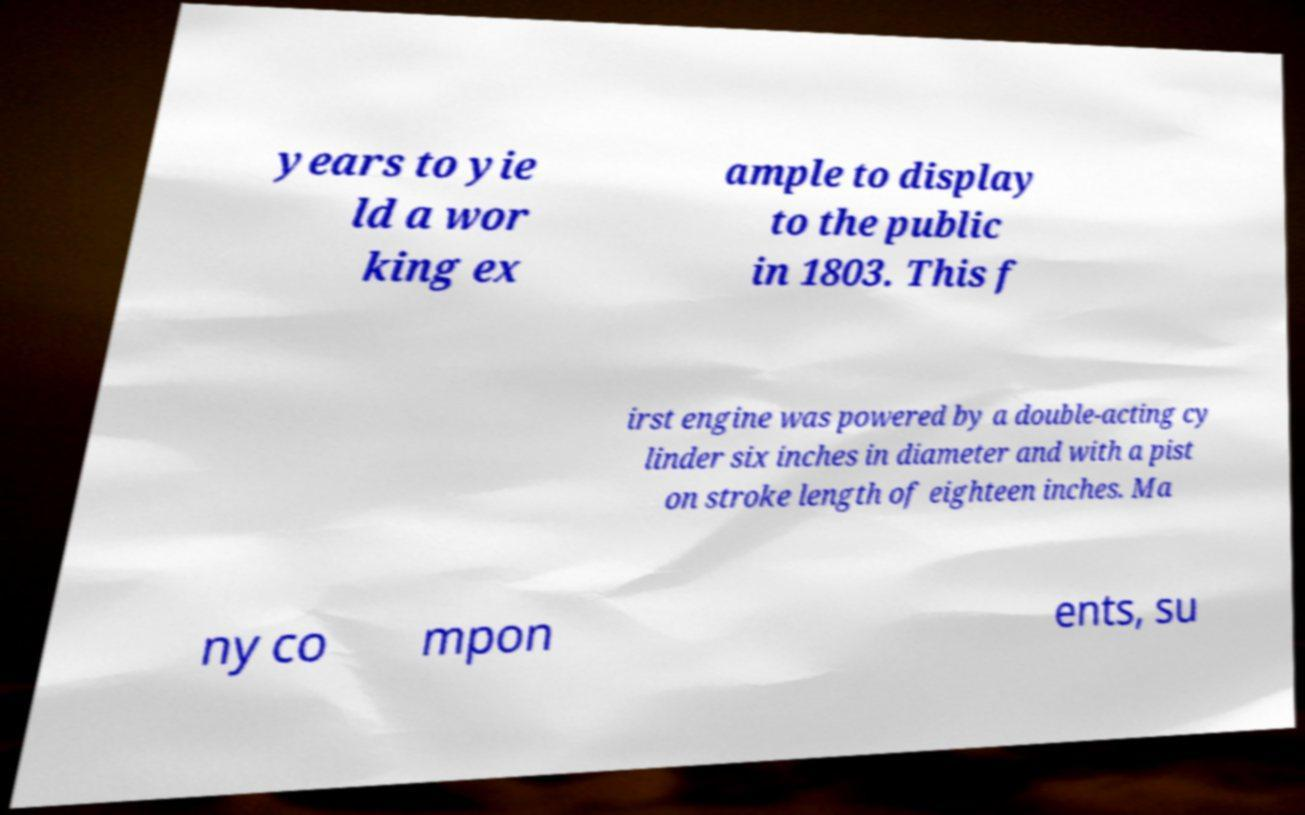Please read and relay the text visible in this image. What does it say? years to yie ld a wor king ex ample to display to the public in 1803. This f irst engine was powered by a double-acting cy linder six inches in diameter and with a pist on stroke length of eighteen inches. Ma ny co mpon ents, su 